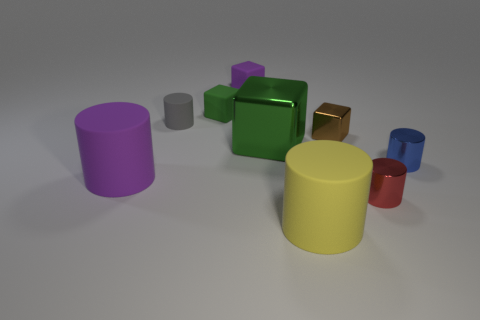Add 1 big green things. How many objects exist? 10 Subtract all tiny red cylinders. How many cylinders are left? 4 Subtract all blocks. How many objects are left? 5 Subtract all big cyan cubes. Subtract all purple rubber objects. How many objects are left? 7 Add 8 small purple cubes. How many small purple cubes are left? 9 Add 3 red matte balls. How many red matte balls exist? 3 Subtract all green blocks. How many blocks are left? 2 Subtract 0 brown balls. How many objects are left? 9 Subtract 2 blocks. How many blocks are left? 2 Subtract all red cylinders. Subtract all yellow spheres. How many cylinders are left? 4 